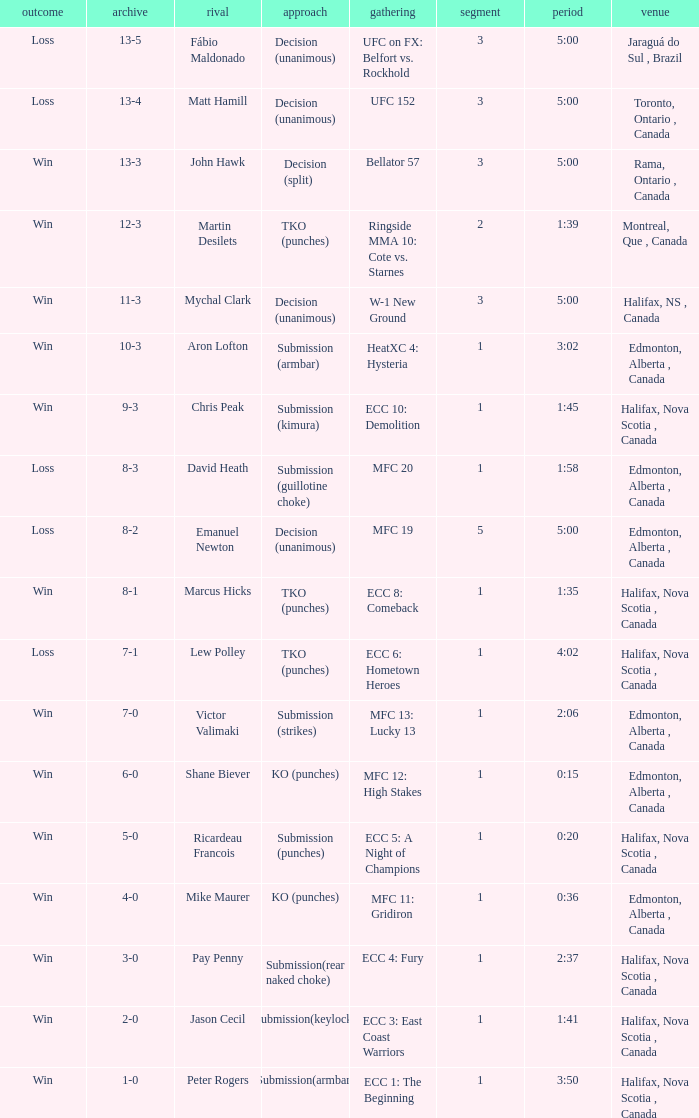Who is the opponent of the match with a win result and a time of 3:02? Aron Lofton. 